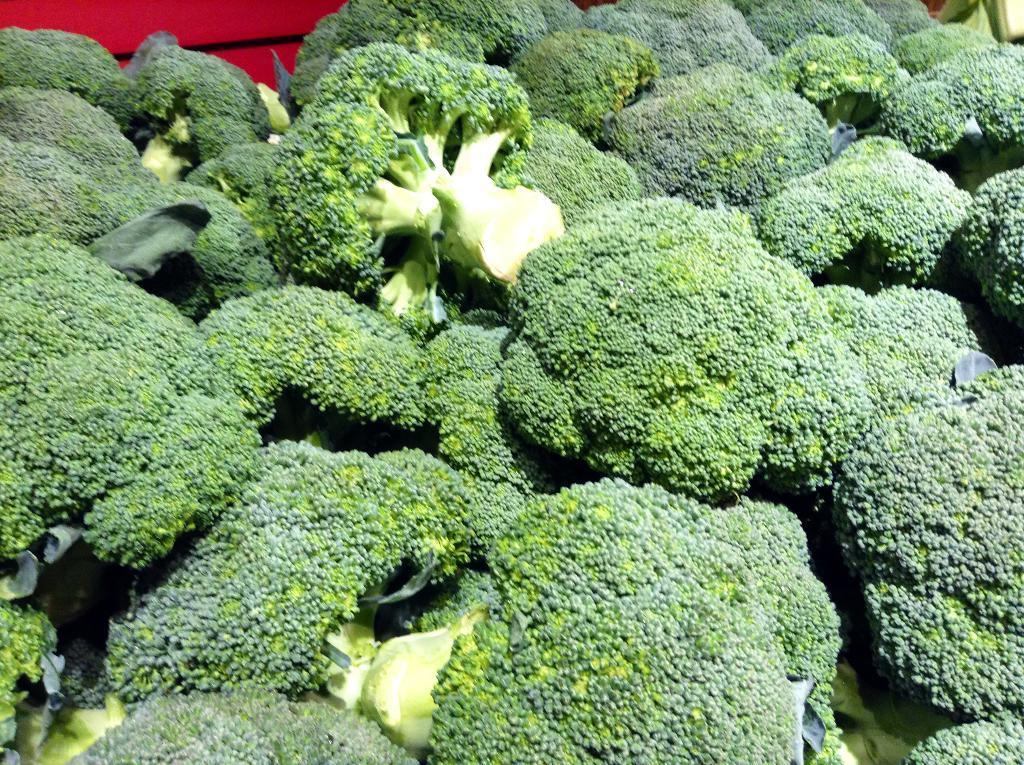Could you give a brief overview of what you see in this image? In this picture I can see few broccoli. 